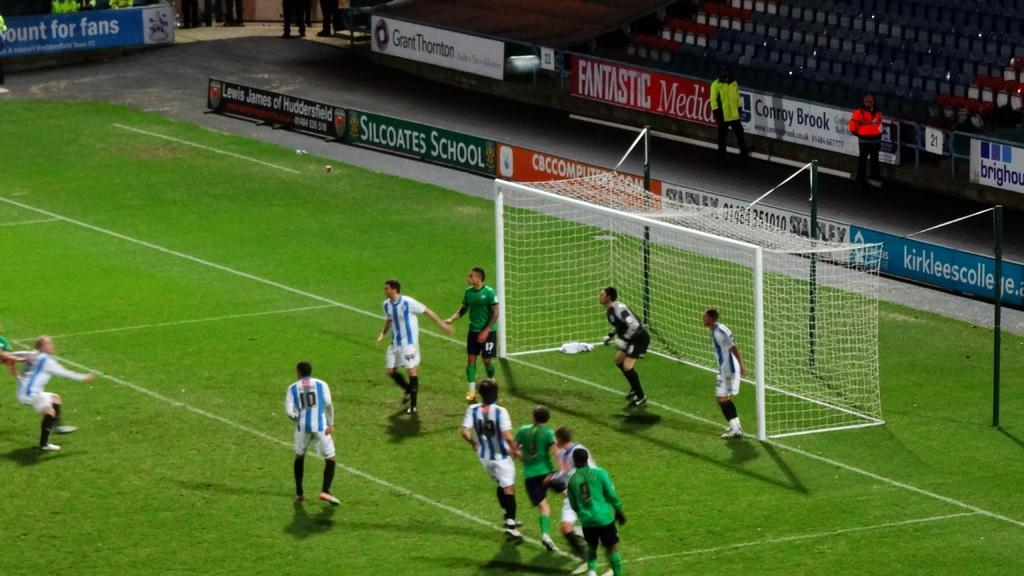What is the surface that the people are standing on in the image? The ground is covered with grass. What can be seen in the image besides the people and grass? There is a net visible in the image. What type of spoon is being used by the farmer in the image? There is no farmer or spoon present in the image. 